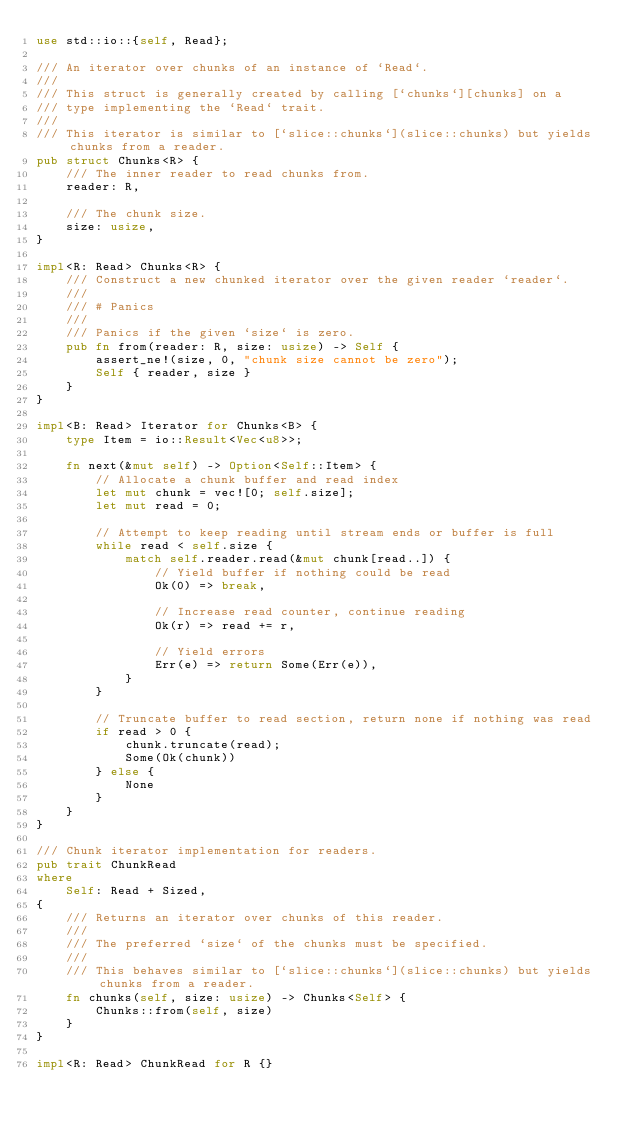<code> <loc_0><loc_0><loc_500><loc_500><_Rust_>use std::io::{self, Read};

/// An iterator over chunks of an instance of `Read`.
///
/// This struct is generally created by calling [`chunks`][chunks] on a
/// type implementing the `Read` trait.
///
/// This iterator is similar to [`slice::chunks`](slice::chunks) but yields chunks from a reader.
pub struct Chunks<R> {
    /// The inner reader to read chunks from.
    reader: R,

    /// The chunk size.
    size: usize,
}

impl<R: Read> Chunks<R> {
    /// Construct a new chunked iterator over the given reader `reader`.
    ///
    /// # Panics
    ///
    /// Panics if the given `size` is zero.
    pub fn from(reader: R, size: usize) -> Self {
        assert_ne!(size, 0, "chunk size cannot be zero");
        Self { reader, size }
    }
}

impl<B: Read> Iterator for Chunks<B> {
    type Item = io::Result<Vec<u8>>;

    fn next(&mut self) -> Option<Self::Item> {
        // Allocate a chunk buffer and read index
        let mut chunk = vec![0; self.size];
        let mut read = 0;

        // Attempt to keep reading until stream ends or buffer is full
        while read < self.size {
            match self.reader.read(&mut chunk[read..]) {
                // Yield buffer if nothing could be read
                Ok(0) => break,

                // Increase read counter, continue reading
                Ok(r) => read += r,

                // Yield errors
                Err(e) => return Some(Err(e)),
            }
        }

        // Truncate buffer to read section, return none if nothing was read
        if read > 0 {
            chunk.truncate(read);
            Some(Ok(chunk))
        } else {
            None
        }
    }
}

/// Chunk iterator implementation for readers.
pub trait ChunkRead
where
    Self: Read + Sized,
{
    /// Returns an iterator over chunks of this reader.
    ///
    /// The preferred `size` of the chunks must be specified.
    ///
    /// This behaves similar to [`slice::chunks`](slice::chunks) but yields chunks from a reader.
    fn chunks(self, size: usize) -> Chunks<Self> {
        Chunks::from(self, size)
    }
}

impl<R: Read> ChunkRead for R {}
</code> 